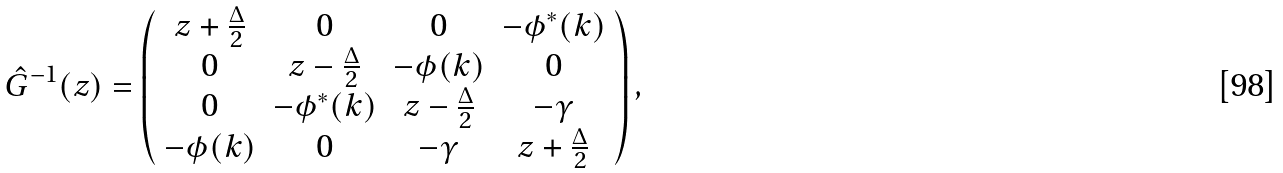<formula> <loc_0><loc_0><loc_500><loc_500>\hat { G } ^ { - 1 } ( z ) = \left ( \begin{array} { c c c c } z + \frac { \Delta } { 2 } & 0 & 0 & - \phi ^ { * } ( { k } ) \\ 0 & z - \frac { \Delta } { 2 } & - \phi ( { k } ) & 0 \\ 0 & - \phi ^ { * } ( { k } ) & z - \frac { \Delta } { 2 } & - \gamma \\ - \phi ( { k } ) & 0 & - \gamma & z + \frac { \Delta } { 2 } \end{array} \right ) ,</formula> 